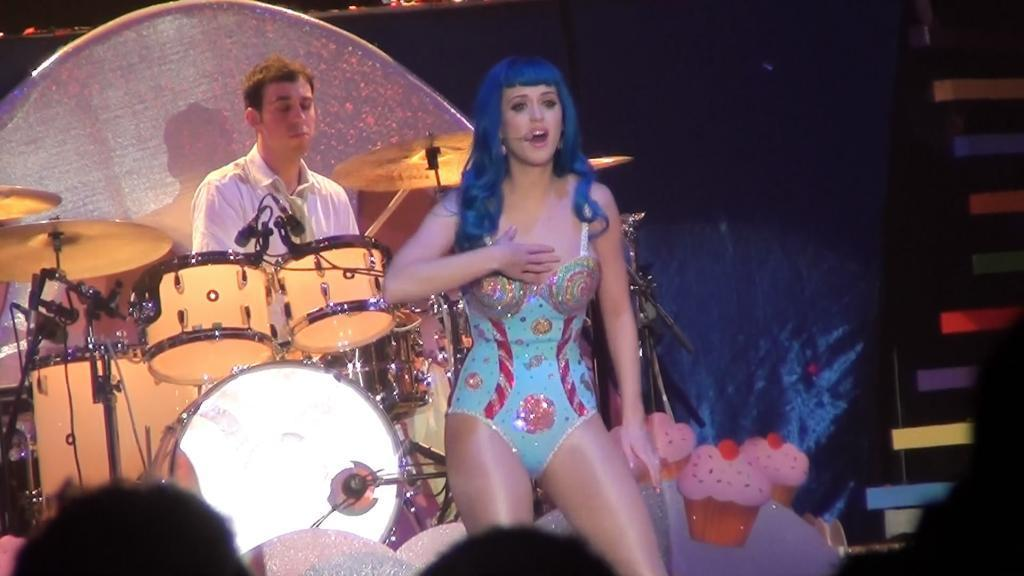Who or what can be seen in the image? There are people in the image. What are the people holding or using in the image? There are microphones (mics) and musical instruments in the image. Can you describe any other objects present in the image? There are some objects in the image. What can be seen in the background of the image? There is a curtain in the background of the image. What type of competition is being held in the image? There is no indication of a competition in the image. The image only shows people with microphones and musical instruments, along with some objects and a curtain in the background. 